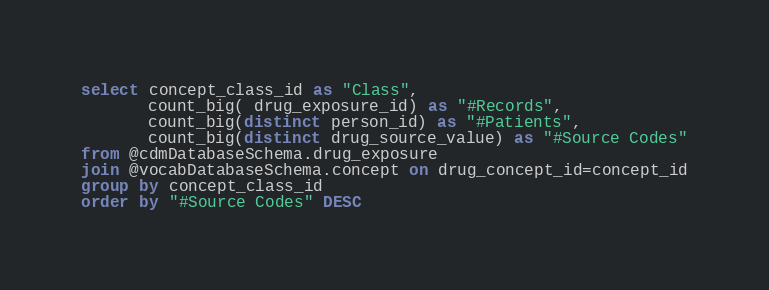Convert code to text. <code><loc_0><loc_0><loc_500><loc_500><_SQL_>
select concept_class_id as "Class",
       count_big( drug_exposure_id) as "#Records",
       count_big(distinct person_id) as "#Patients",
       count_big(distinct drug_source_value) as "#Source Codes"
from @cdmDatabaseSchema.drug_exposure
join @vocabDatabaseSchema.concept on drug_concept_id=concept_id
group by concept_class_id
order by "#Source Codes" DESC
</code> 